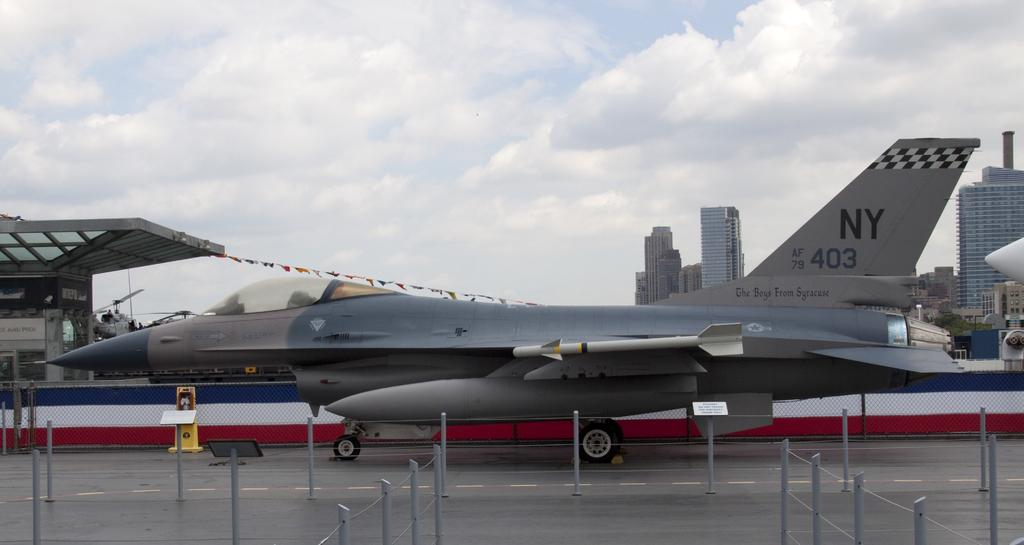<image>
Give a short and clear explanation of the subsequent image. A fighter jet with the letters NY on it's tail is sitting on a runway in a city. 